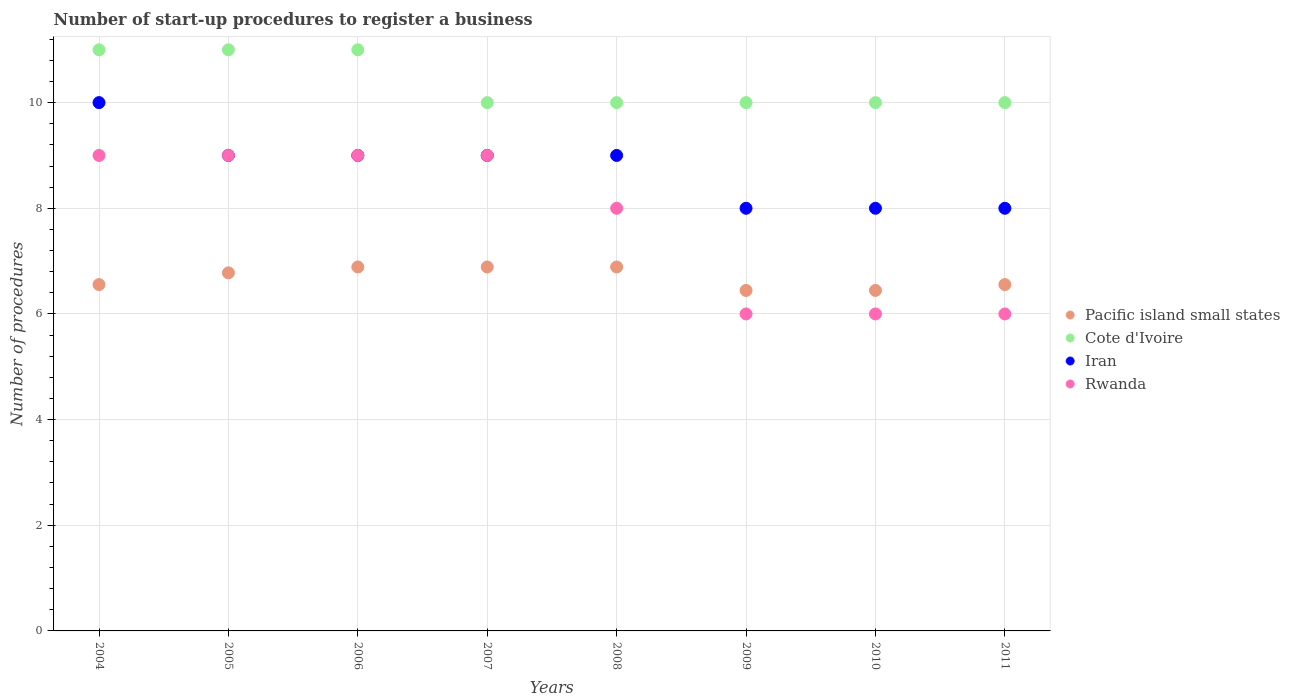How many different coloured dotlines are there?
Provide a short and direct response. 4. What is the number of procedures required to register a business in Iran in 2009?
Give a very brief answer. 8. Across all years, what is the maximum number of procedures required to register a business in Pacific island small states?
Offer a terse response. 6.89. Across all years, what is the minimum number of procedures required to register a business in Cote d'Ivoire?
Provide a short and direct response. 10. In which year was the number of procedures required to register a business in Rwanda maximum?
Your answer should be very brief. 2004. What is the total number of procedures required to register a business in Cote d'Ivoire in the graph?
Ensure brevity in your answer.  83. What is the difference between the number of procedures required to register a business in Cote d'Ivoire in 2009 and that in 2010?
Ensure brevity in your answer.  0. What is the difference between the number of procedures required to register a business in Rwanda in 2006 and the number of procedures required to register a business in Pacific island small states in 2004?
Your answer should be compact. 2.44. What is the average number of procedures required to register a business in Rwanda per year?
Provide a short and direct response. 7.75. In the year 2010, what is the difference between the number of procedures required to register a business in Pacific island small states and number of procedures required to register a business in Rwanda?
Your answer should be compact. 0.44. Is the difference between the number of procedures required to register a business in Pacific island small states in 2007 and 2009 greater than the difference between the number of procedures required to register a business in Rwanda in 2007 and 2009?
Offer a terse response. No. What is the difference between the highest and the lowest number of procedures required to register a business in Iran?
Offer a terse response. 2. In how many years, is the number of procedures required to register a business in Cote d'Ivoire greater than the average number of procedures required to register a business in Cote d'Ivoire taken over all years?
Provide a succinct answer. 3. Does the number of procedures required to register a business in Cote d'Ivoire monotonically increase over the years?
Give a very brief answer. No. Is the number of procedures required to register a business in Iran strictly greater than the number of procedures required to register a business in Rwanda over the years?
Your answer should be compact. No. Is the number of procedures required to register a business in Cote d'Ivoire strictly less than the number of procedures required to register a business in Rwanda over the years?
Offer a very short reply. No. How many dotlines are there?
Your response must be concise. 4. Does the graph contain any zero values?
Your answer should be very brief. No. Does the graph contain grids?
Your answer should be very brief. Yes. Where does the legend appear in the graph?
Provide a succinct answer. Center right. How are the legend labels stacked?
Your answer should be very brief. Vertical. What is the title of the graph?
Your answer should be compact. Number of start-up procedures to register a business. Does "Argentina" appear as one of the legend labels in the graph?
Keep it short and to the point. No. What is the label or title of the X-axis?
Your response must be concise. Years. What is the label or title of the Y-axis?
Make the answer very short. Number of procedures. What is the Number of procedures in Pacific island small states in 2004?
Keep it short and to the point. 6.56. What is the Number of procedures of Cote d'Ivoire in 2004?
Give a very brief answer. 11. What is the Number of procedures in Iran in 2004?
Your answer should be compact. 10. What is the Number of procedures of Pacific island small states in 2005?
Offer a terse response. 6.78. What is the Number of procedures in Cote d'Ivoire in 2005?
Keep it short and to the point. 11. What is the Number of procedures in Rwanda in 2005?
Your answer should be compact. 9. What is the Number of procedures of Pacific island small states in 2006?
Keep it short and to the point. 6.89. What is the Number of procedures in Rwanda in 2006?
Keep it short and to the point. 9. What is the Number of procedures of Pacific island small states in 2007?
Offer a very short reply. 6.89. What is the Number of procedures of Cote d'Ivoire in 2007?
Offer a very short reply. 10. What is the Number of procedures of Rwanda in 2007?
Give a very brief answer. 9. What is the Number of procedures of Pacific island small states in 2008?
Make the answer very short. 6.89. What is the Number of procedures of Cote d'Ivoire in 2008?
Offer a terse response. 10. What is the Number of procedures in Rwanda in 2008?
Your answer should be very brief. 8. What is the Number of procedures of Pacific island small states in 2009?
Ensure brevity in your answer.  6.44. What is the Number of procedures in Rwanda in 2009?
Ensure brevity in your answer.  6. What is the Number of procedures of Pacific island small states in 2010?
Your answer should be compact. 6.44. What is the Number of procedures in Rwanda in 2010?
Provide a succinct answer. 6. What is the Number of procedures of Pacific island small states in 2011?
Your response must be concise. 6.56. What is the Number of procedures of Rwanda in 2011?
Ensure brevity in your answer.  6. Across all years, what is the maximum Number of procedures in Pacific island small states?
Keep it short and to the point. 6.89. Across all years, what is the minimum Number of procedures in Pacific island small states?
Offer a very short reply. 6.44. Across all years, what is the minimum Number of procedures in Iran?
Give a very brief answer. 8. Across all years, what is the minimum Number of procedures in Rwanda?
Your answer should be very brief. 6. What is the total Number of procedures in Pacific island small states in the graph?
Ensure brevity in your answer.  53.44. What is the total Number of procedures in Cote d'Ivoire in the graph?
Provide a short and direct response. 83. What is the total Number of procedures of Iran in the graph?
Ensure brevity in your answer.  70. What is the difference between the Number of procedures in Pacific island small states in 2004 and that in 2005?
Make the answer very short. -0.22. What is the difference between the Number of procedures in Iran in 2004 and that in 2006?
Your answer should be very brief. 1. What is the difference between the Number of procedures in Rwanda in 2004 and that in 2006?
Ensure brevity in your answer.  0. What is the difference between the Number of procedures in Pacific island small states in 2004 and that in 2007?
Keep it short and to the point. -0.33. What is the difference between the Number of procedures in Cote d'Ivoire in 2004 and that in 2007?
Provide a short and direct response. 1. What is the difference between the Number of procedures of Iran in 2004 and that in 2007?
Offer a terse response. 1. What is the difference between the Number of procedures of Rwanda in 2004 and that in 2007?
Provide a succinct answer. 0. What is the difference between the Number of procedures of Pacific island small states in 2004 and that in 2008?
Keep it short and to the point. -0.33. What is the difference between the Number of procedures of Iran in 2004 and that in 2008?
Make the answer very short. 1. What is the difference between the Number of procedures in Rwanda in 2004 and that in 2008?
Ensure brevity in your answer.  1. What is the difference between the Number of procedures in Cote d'Ivoire in 2004 and that in 2009?
Ensure brevity in your answer.  1. What is the difference between the Number of procedures of Cote d'Ivoire in 2004 and that in 2010?
Your answer should be compact. 1. What is the difference between the Number of procedures of Rwanda in 2004 and that in 2010?
Make the answer very short. 3. What is the difference between the Number of procedures in Pacific island small states in 2004 and that in 2011?
Your answer should be compact. 0. What is the difference between the Number of procedures of Cote d'Ivoire in 2004 and that in 2011?
Your response must be concise. 1. What is the difference between the Number of procedures of Iran in 2004 and that in 2011?
Ensure brevity in your answer.  2. What is the difference between the Number of procedures in Pacific island small states in 2005 and that in 2006?
Ensure brevity in your answer.  -0.11. What is the difference between the Number of procedures of Rwanda in 2005 and that in 2006?
Your answer should be compact. 0. What is the difference between the Number of procedures in Pacific island small states in 2005 and that in 2007?
Provide a short and direct response. -0.11. What is the difference between the Number of procedures of Iran in 2005 and that in 2007?
Provide a succinct answer. 0. What is the difference between the Number of procedures of Rwanda in 2005 and that in 2007?
Provide a succinct answer. 0. What is the difference between the Number of procedures of Pacific island small states in 2005 and that in 2008?
Your answer should be very brief. -0.11. What is the difference between the Number of procedures of Iran in 2005 and that in 2008?
Offer a very short reply. 0. What is the difference between the Number of procedures of Pacific island small states in 2005 and that in 2009?
Ensure brevity in your answer.  0.33. What is the difference between the Number of procedures in Iran in 2005 and that in 2009?
Your response must be concise. 1. What is the difference between the Number of procedures of Pacific island small states in 2005 and that in 2010?
Your answer should be compact. 0.33. What is the difference between the Number of procedures in Rwanda in 2005 and that in 2010?
Provide a short and direct response. 3. What is the difference between the Number of procedures of Pacific island small states in 2005 and that in 2011?
Your answer should be very brief. 0.22. What is the difference between the Number of procedures of Cote d'Ivoire in 2005 and that in 2011?
Your answer should be very brief. 1. What is the difference between the Number of procedures of Iran in 2005 and that in 2011?
Your response must be concise. 1. What is the difference between the Number of procedures in Cote d'Ivoire in 2006 and that in 2007?
Your answer should be very brief. 1. What is the difference between the Number of procedures in Rwanda in 2006 and that in 2007?
Offer a very short reply. 0. What is the difference between the Number of procedures in Pacific island small states in 2006 and that in 2008?
Provide a succinct answer. 0. What is the difference between the Number of procedures in Rwanda in 2006 and that in 2008?
Offer a terse response. 1. What is the difference between the Number of procedures of Pacific island small states in 2006 and that in 2009?
Keep it short and to the point. 0.44. What is the difference between the Number of procedures of Cote d'Ivoire in 2006 and that in 2009?
Ensure brevity in your answer.  1. What is the difference between the Number of procedures in Iran in 2006 and that in 2009?
Keep it short and to the point. 1. What is the difference between the Number of procedures of Pacific island small states in 2006 and that in 2010?
Make the answer very short. 0.44. What is the difference between the Number of procedures of Cote d'Ivoire in 2006 and that in 2010?
Ensure brevity in your answer.  1. What is the difference between the Number of procedures in Rwanda in 2006 and that in 2010?
Your response must be concise. 3. What is the difference between the Number of procedures in Pacific island small states in 2006 and that in 2011?
Your response must be concise. 0.33. What is the difference between the Number of procedures of Cote d'Ivoire in 2006 and that in 2011?
Your answer should be compact. 1. What is the difference between the Number of procedures in Pacific island small states in 2007 and that in 2008?
Give a very brief answer. 0. What is the difference between the Number of procedures of Iran in 2007 and that in 2008?
Ensure brevity in your answer.  0. What is the difference between the Number of procedures in Rwanda in 2007 and that in 2008?
Offer a very short reply. 1. What is the difference between the Number of procedures of Pacific island small states in 2007 and that in 2009?
Ensure brevity in your answer.  0.44. What is the difference between the Number of procedures of Rwanda in 2007 and that in 2009?
Keep it short and to the point. 3. What is the difference between the Number of procedures of Pacific island small states in 2007 and that in 2010?
Keep it short and to the point. 0.44. What is the difference between the Number of procedures of Pacific island small states in 2007 and that in 2011?
Provide a succinct answer. 0.33. What is the difference between the Number of procedures of Iran in 2007 and that in 2011?
Make the answer very short. 1. What is the difference between the Number of procedures in Pacific island small states in 2008 and that in 2009?
Your answer should be very brief. 0.44. What is the difference between the Number of procedures in Pacific island small states in 2008 and that in 2010?
Ensure brevity in your answer.  0.44. What is the difference between the Number of procedures of Cote d'Ivoire in 2008 and that in 2010?
Offer a terse response. 0. What is the difference between the Number of procedures in Rwanda in 2008 and that in 2010?
Provide a short and direct response. 2. What is the difference between the Number of procedures in Pacific island small states in 2008 and that in 2011?
Make the answer very short. 0.33. What is the difference between the Number of procedures in Cote d'Ivoire in 2008 and that in 2011?
Keep it short and to the point. 0. What is the difference between the Number of procedures in Rwanda in 2008 and that in 2011?
Your answer should be very brief. 2. What is the difference between the Number of procedures in Iran in 2009 and that in 2010?
Provide a succinct answer. 0. What is the difference between the Number of procedures in Pacific island small states in 2009 and that in 2011?
Keep it short and to the point. -0.11. What is the difference between the Number of procedures of Cote d'Ivoire in 2009 and that in 2011?
Offer a very short reply. 0. What is the difference between the Number of procedures of Iran in 2009 and that in 2011?
Your answer should be compact. 0. What is the difference between the Number of procedures of Rwanda in 2009 and that in 2011?
Offer a very short reply. 0. What is the difference between the Number of procedures in Pacific island small states in 2010 and that in 2011?
Provide a short and direct response. -0.11. What is the difference between the Number of procedures of Rwanda in 2010 and that in 2011?
Your response must be concise. 0. What is the difference between the Number of procedures of Pacific island small states in 2004 and the Number of procedures of Cote d'Ivoire in 2005?
Provide a short and direct response. -4.44. What is the difference between the Number of procedures of Pacific island small states in 2004 and the Number of procedures of Iran in 2005?
Provide a short and direct response. -2.44. What is the difference between the Number of procedures of Pacific island small states in 2004 and the Number of procedures of Rwanda in 2005?
Ensure brevity in your answer.  -2.44. What is the difference between the Number of procedures in Cote d'Ivoire in 2004 and the Number of procedures in Iran in 2005?
Your answer should be compact. 2. What is the difference between the Number of procedures in Iran in 2004 and the Number of procedures in Rwanda in 2005?
Give a very brief answer. 1. What is the difference between the Number of procedures in Pacific island small states in 2004 and the Number of procedures in Cote d'Ivoire in 2006?
Offer a very short reply. -4.44. What is the difference between the Number of procedures of Pacific island small states in 2004 and the Number of procedures of Iran in 2006?
Your answer should be compact. -2.44. What is the difference between the Number of procedures in Pacific island small states in 2004 and the Number of procedures in Rwanda in 2006?
Keep it short and to the point. -2.44. What is the difference between the Number of procedures in Cote d'Ivoire in 2004 and the Number of procedures in Iran in 2006?
Keep it short and to the point. 2. What is the difference between the Number of procedures in Cote d'Ivoire in 2004 and the Number of procedures in Rwanda in 2006?
Give a very brief answer. 2. What is the difference between the Number of procedures of Pacific island small states in 2004 and the Number of procedures of Cote d'Ivoire in 2007?
Ensure brevity in your answer.  -3.44. What is the difference between the Number of procedures in Pacific island small states in 2004 and the Number of procedures in Iran in 2007?
Your response must be concise. -2.44. What is the difference between the Number of procedures of Pacific island small states in 2004 and the Number of procedures of Rwanda in 2007?
Your answer should be very brief. -2.44. What is the difference between the Number of procedures in Cote d'Ivoire in 2004 and the Number of procedures in Iran in 2007?
Provide a short and direct response. 2. What is the difference between the Number of procedures of Pacific island small states in 2004 and the Number of procedures of Cote d'Ivoire in 2008?
Give a very brief answer. -3.44. What is the difference between the Number of procedures in Pacific island small states in 2004 and the Number of procedures in Iran in 2008?
Offer a very short reply. -2.44. What is the difference between the Number of procedures in Pacific island small states in 2004 and the Number of procedures in Rwanda in 2008?
Offer a terse response. -1.44. What is the difference between the Number of procedures in Cote d'Ivoire in 2004 and the Number of procedures in Iran in 2008?
Offer a terse response. 2. What is the difference between the Number of procedures in Iran in 2004 and the Number of procedures in Rwanda in 2008?
Ensure brevity in your answer.  2. What is the difference between the Number of procedures of Pacific island small states in 2004 and the Number of procedures of Cote d'Ivoire in 2009?
Your answer should be compact. -3.44. What is the difference between the Number of procedures in Pacific island small states in 2004 and the Number of procedures in Iran in 2009?
Your answer should be compact. -1.44. What is the difference between the Number of procedures of Pacific island small states in 2004 and the Number of procedures of Rwanda in 2009?
Your response must be concise. 0.56. What is the difference between the Number of procedures of Cote d'Ivoire in 2004 and the Number of procedures of Iran in 2009?
Provide a short and direct response. 3. What is the difference between the Number of procedures of Cote d'Ivoire in 2004 and the Number of procedures of Rwanda in 2009?
Your answer should be compact. 5. What is the difference between the Number of procedures of Pacific island small states in 2004 and the Number of procedures of Cote d'Ivoire in 2010?
Offer a very short reply. -3.44. What is the difference between the Number of procedures of Pacific island small states in 2004 and the Number of procedures of Iran in 2010?
Offer a very short reply. -1.44. What is the difference between the Number of procedures of Pacific island small states in 2004 and the Number of procedures of Rwanda in 2010?
Provide a short and direct response. 0.56. What is the difference between the Number of procedures of Cote d'Ivoire in 2004 and the Number of procedures of Iran in 2010?
Ensure brevity in your answer.  3. What is the difference between the Number of procedures of Iran in 2004 and the Number of procedures of Rwanda in 2010?
Provide a short and direct response. 4. What is the difference between the Number of procedures in Pacific island small states in 2004 and the Number of procedures in Cote d'Ivoire in 2011?
Make the answer very short. -3.44. What is the difference between the Number of procedures of Pacific island small states in 2004 and the Number of procedures of Iran in 2011?
Your response must be concise. -1.44. What is the difference between the Number of procedures of Pacific island small states in 2004 and the Number of procedures of Rwanda in 2011?
Give a very brief answer. 0.56. What is the difference between the Number of procedures of Cote d'Ivoire in 2004 and the Number of procedures of Iran in 2011?
Make the answer very short. 3. What is the difference between the Number of procedures of Iran in 2004 and the Number of procedures of Rwanda in 2011?
Your response must be concise. 4. What is the difference between the Number of procedures of Pacific island small states in 2005 and the Number of procedures of Cote d'Ivoire in 2006?
Give a very brief answer. -4.22. What is the difference between the Number of procedures in Pacific island small states in 2005 and the Number of procedures in Iran in 2006?
Make the answer very short. -2.22. What is the difference between the Number of procedures of Pacific island small states in 2005 and the Number of procedures of Rwanda in 2006?
Make the answer very short. -2.22. What is the difference between the Number of procedures in Cote d'Ivoire in 2005 and the Number of procedures in Rwanda in 2006?
Keep it short and to the point. 2. What is the difference between the Number of procedures in Pacific island small states in 2005 and the Number of procedures in Cote d'Ivoire in 2007?
Make the answer very short. -3.22. What is the difference between the Number of procedures in Pacific island small states in 2005 and the Number of procedures in Iran in 2007?
Offer a terse response. -2.22. What is the difference between the Number of procedures of Pacific island small states in 2005 and the Number of procedures of Rwanda in 2007?
Make the answer very short. -2.22. What is the difference between the Number of procedures of Cote d'Ivoire in 2005 and the Number of procedures of Iran in 2007?
Offer a very short reply. 2. What is the difference between the Number of procedures in Cote d'Ivoire in 2005 and the Number of procedures in Rwanda in 2007?
Offer a terse response. 2. What is the difference between the Number of procedures in Pacific island small states in 2005 and the Number of procedures in Cote d'Ivoire in 2008?
Give a very brief answer. -3.22. What is the difference between the Number of procedures in Pacific island small states in 2005 and the Number of procedures in Iran in 2008?
Your answer should be very brief. -2.22. What is the difference between the Number of procedures of Pacific island small states in 2005 and the Number of procedures of Rwanda in 2008?
Your answer should be very brief. -1.22. What is the difference between the Number of procedures in Cote d'Ivoire in 2005 and the Number of procedures in Iran in 2008?
Give a very brief answer. 2. What is the difference between the Number of procedures in Pacific island small states in 2005 and the Number of procedures in Cote d'Ivoire in 2009?
Give a very brief answer. -3.22. What is the difference between the Number of procedures in Pacific island small states in 2005 and the Number of procedures in Iran in 2009?
Ensure brevity in your answer.  -1.22. What is the difference between the Number of procedures of Cote d'Ivoire in 2005 and the Number of procedures of Iran in 2009?
Offer a very short reply. 3. What is the difference between the Number of procedures in Cote d'Ivoire in 2005 and the Number of procedures in Rwanda in 2009?
Provide a short and direct response. 5. What is the difference between the Number of procedures in Pacific island small states in 2005 and the Number of procedures in Cote d'Ivoire in 2010?
Your answer should be very brief. -3.22. What is the difference between the Number of procedures of Pacific island small states in 2005 and the Number of procedures of Iran in 2010?
Offer a very short reply. -1.22. What is the difference between the Number of procedures of Pacific island small states in 2005 and the Number of procedures of Rwanda in 2010?
Offer a terse response. 0.78. What is the difference between the Number of procedures in Cote d'Ivoire in 2005 and the Number of procedures in Iran in 2010?
Offer a very short reply. 3. What is the difference between the Number of procedures of Pacific island small states in 2005 and the Number of procedures of Cote d'Ivoire in 2011?
Your response must be concise. -3.22. What is the difference between the Number of procedures of Pacific island small states in 2005 and the Number of procedures of Iran in 2011?
Provide a short and direct response. -1.22. What is the difference between the Number of procedures of Pacific island small states in 2006 and the Number of procedures of Cote d'Ivoire in 2007?
Your answer should be compact. -3.11. What is the difference between the Number of procedures of Pacific island small states in 2006 and the Number of procedures of Iran in 2007?
Make the answer very short. -2.11. What is the difference between the Number of procedures of Pacific island small states in 2006 and the Number of procedures of Rwanda in 2007?
Provide a succinct answer. -2.11. What is the difference between the Number of procedures in Cote d'Ivoire in 2006 and the Number of procedures in Rwanda in 2007?
Make the answer very short. 2. What is the difference between the Number of procedures of Pacific island small states in 2006 and the Number of procedures of Cote d'Ivoire in 2008?
Offer a very short reply. -3.11. What is the difference between the Number of procedures of Pacific island small states in 2006 and the Number of procedures of Iran in 2008?
Your answer should be very brief. -2.11. What is the difference between the Number of procedures in Pacific island small states in 2006 and the Number of procedures in Rwanda in 2008?
Your answer should be compact. -1.11. What is the difference between the Number of procedures of Cote d'Ivoire in 2006 and the Number of procedures of Iran in 2008?
Make the answer very short. 2. What is the difference between the Number of procedures of Iran in 2006 and the Number of procedures of Rwanda in 2008?
Give a very brief answer. 1. What is the difference between the Number of procedures in Pacific island small states in 2006 and the Number of procedures in Cote d'Ivoire in 2009?
Ensure brevity in your answer.  -3.11. What is the difference between the Number of procedures of Pacific island small states in 2006 and the Number of procedures of Iran in 2009?
Your answer should be very brief. -1.11. What is the difference between the Number of procedures in Cote d'Ivoire in 2006 and the Number of procedures in Iran in 2009?
Ensure brevity in your answer.  3. What is the difference between the Number of procedures in Cote d'Ivoire in 2006 and the Number of procedures in Rwanda in 2009?
Your answer should be compact. 5. What is the difference between the Number of procedures in Pacific island small states in 2006 and the Number of procedures in Cote d'Ivoire in 2010?
Give a very brief answer. -3.11. What is the difference between the Number of procedures in Pacific island small states in 2006 and the Number of procedures in Iran in 2010?
Your answer should be very brief. -1.11. What is the difference between the Number of procedures of Cote d'Ivoire in 2006 and the Number of procedures of Iran in 2010?
Provide a short and direct response. 3. What is the difference between the Number of procedures of Cote d'Ivoire in 2006 and the Number of procedures of Rwanda in 2010?
Offer a terse response. 5. What is the difference between the Number of procedures in Iran in 2006 and the Number of procedures in Rwanda in 2010?
Keep it short and to the point. 3. What is the difference between the Number of procedures in Pacific island small states in 2006 and the Number of procedures in Cote d'Ivoire in 2011?
Provide a succinct answer. -3.11. What is the difference between the Number of procedures of Pacific island small states in 2006 and the Number of procedures of Iran in 2011?
Your answer should be very brief. -1.11. What is the difference between the Number of procedures of Cote d'Ivoire in 2006 and the Number of procedures of Rwanda in 2011?
Provide a short and direct response. 5. What is the difference between the Number of procedures of Pacific island small states in 2007 and the Number of procedures of Cote d'Ivoire in 2008?
Offer a very short reply. -3.11. What is the difference between the Number of procedures of Pacific island small states in 2007 and the Number of procedures of Iran in 2008?
Make the answer very short. -2.11. What is the difference between the Number of procedures of Pacific island small states in 2007 and the Number of procedures of Rwanda in 2008?
Provide a succinct answer. -1.11. What is the difference between the Number of procedures in Pacific island small states in 2007 and the Number of procedures in Cote d'Ivoire in 2009?
Ensure brevity in your answer.  -3.11. What is the difference between the Number of procedures in Pacific island small states in 2007 and the Number of procedures in Iran in 2009?
Make the answer very short. -1.11. What is the difference between the Number of procedures of Pacific island small states in 2007 and the Number of procedures of Rwanda in 2009?
Make the answer very short. 0.89. What is the difference between the Number of procedures of Cote d'Ivoire in 2007 and the Number of procedures of Rwanda in 2009?
Provide a short and direct response. 4. What is the difference between the Number of procedures of Pacific island small states in 2007 and the Number of procedures of Cote d'Ivoire in 2010?
Make the answer very short. -3.11. What is the difference between the Number of procedures in Pacific island small states in 2007 and the Number of procedures in Iran in 2010?
Your answer should be compact. -1.11. What is the difference between the Number of procedures of Cote d'Ivoire in 2007 and the Number of procedures of Iran in 2010?
Provide a succinct answer. 2. What is the difference between the Number of procedures in Cote d'Ivoire in 2007 and the Number of procedures in Rwanda in 2010?
Offer a terse response. 4. What is the difference between the Number of procedures of Iran in 2007 and the Number of procedures of Rwanda in 2010?
Make the answer very short. 3. What is the difference between the Number of procedures of Pacific island small states in 2007 and the Number of procedures of Cote d'Ivoire in 2011?
Make the answer very short. -3.11. What is the difference between the Number of procedures of Pacific island small states in 2007 and the Number of procedures of Iran in 2011?
Make the answer very short. -1.11. What is the difference between the Number of procedures of Pacific island small states in 2007 and the Number of procedures of Rwanda in 2011?
Your answer should be very brief. 0.89. What is the difference between the Number of procedures in Cote d'Ivoire in 2007 and the Number of procedures in Rwanda in 2011?
Provide a short and direct response. 4. What is the difference between the Number of procedures in Pacific island small states in 2008 and the Number of procedures in Cote d'Ivoire in 2009?
Your answer should be very brief. -3.11. What is the difference between the Number of procedures in Pacific island small states in 2008 and the Number of procedures in Iran in 2009?
Your answer should be very brief. -1.11. What is the difference between the Number of procedures of Pacific island small states in 2008 and the Number of procedures of Rwanda in 2009?
Offer a terse response. 0.89. What is the difference between the Number of procedures of Iran in 2008 and the Number of procedures of Rwanda in 2009?
Offer a terse response. 3. What is the difference between the Number of procedures of Pacific island small states in 2008 and the Number of procedures of Cote d'Ivoire in 2010?
Your answer should be very brief. -3.11. What is the difference between the Number of procedures of Pacific island small states in 2008 and the Number of procedures of Iran in 2010?
Offer a terse response. -1.11. What is the difference between the Number of procedures in Pacific island small states in 2008 and the Number of procedures in Rwanda in 2010?
Your response must be concise. 0.89. What is the difference between the Number of procedures in Iran in 2008 and the Number of procedures in Rwanda in 2010?
Ensure brevity in your answer.  3. What is the difference between the Number of procedures in Pacific island small states in 2008 and the Number of procedures in Cote d'Ivoire in 2011?
Your response must be concise. -3.11. What is the difference between the Number of procedures in Pacific island small states in 2008 and the Number of procedures in Iran in 2011?
Your answer should be compact. -1.11. What is the difference between the Number of procedures of Pacific island small states in 2008 and the Number of procedures of Rwanda in 2011?
Your answer should be very brief. 0.89. What is the difference between the Number of procedures in Cote d'Ivoire in 2008 and the Number of procedures in Rwanda in 2011?
Offer a terse response. 4. What is the difference between the Number of procedures of Pacific island small states in 2009 and the Number of procedures of Cote d'Ivoire in 2010?
Keep it short and to the point. -3.56. What is the difference between the Number of procedures of Pacific island small states in 2009 and the Number of procedures of Iran in 2010?
Offer a terse response. -1.56. What is the difference between the Number of procedures of Pacific island small states in 2009 and the Number of procedures of Rwanda in 2010?
Your response must be concise. 0.44. What is the difference between the Number of procedures of Cote d'Ivoire in 2009 and the Number of procedures of Iran in 2010?
Offer a terse response. 2. What is the difference between the Number of procedures of Cote d'Ivoire in 2009 and the Number of procedures of Rwanda in 2010?
Make the answer very short. 4. What is the difference between the Number of procedures of Pacific island small states in 2009 and the Number of procedures of Cote d'Ivoire in 2011?
Provide a succinct answer. -3.56. What is the difference between the Number of procedures of Pacific island small states in 2009 and the Number of procedures of Iran in 2011?
Keep it short and to the point. -1.56. What is the difference between the Number of procedures of Pacific island small states in 2009 and the Number of procedures of Rwanda in 2011?
Offer a very short reply. 0.44. What is the difference between the Number of procedures in Cote d'Ivoire in 2009 and the Number of procedures in Rwanda in 2011?
Your answer should be very brief. 4. What is the difference between the Number of procedures of Pacific island small states in 2010 and the Number of procedures of Cote d'Ivoire in 2011?
Make the answer very short. -3.56. What is the difference between the Number of procedures in Pacific island small states in 2010 and the Number of procedures in Iran in 2011?
Provide a succinct answer. -1.56. What is the difference between the Number of procedures in Pacific island small states in 2010 and the Number of procedures in Rwanda in 2011?
Offer a terse response. 0.44. What is the difference between the Number of procedures in Cote d'Ivoire in 2010 and the Number of procedures in Rwanda in 2011?
Your answer should be very brief. 4. What is the average Number of procedures of Pacific island small states per year?
Make the answer very short. 6.68. What is the average Number of procedures in Cote d'Ivoire per year?
Your answer should be very brief. 10.38. What is the average Number of procedures of Iran per year?
Ensure brevity in your answer.  8.75. What is the average Number of procedures of Rwanda per year?
Ensure brevity in your answer.  7.75. In the year 2004, what is the difference between the Number of procedures of Pacific island small states and Number of procedures of Cote d'Ivoire?
Offer a very short reply. -4.44. In the year 2004, what is the difference between the Number of procedures in Pacific island small states and Number of procedures in Iran?
Offer a terse response. -3.44. In the year 2004, what is the difference between the Number of procedures in Pacific island small states and Number of procedures in Rwanda?
Your response must be concise. -2.44. In the year 2004, what is the difference between the Number of procedures of Cote d'Ivoire and Number of procedures of Iran?
Offer a terse response. 1. In the year 2005, what is the difference between the Number of procedures of Pacific island small states and Number of procedures of Cote d'Ivoire?
Make the answer very short. -4.22. In the year 2005, what is the difference between the Number of procedures in Pacific island small states and Number of procedures in Iran?
Offer a terse response. -2.22. In the year 2005, what is the difference between the Number of procedures in Pacific island small states and Number of procedures in Rwanda?
Offer a terse response. -2.22. In the year 2006, what is the difference between the Number of procedures in Pacific island small states and Number of procedures in Cote d'Ivoire?
Offer a terse response. -4.11. In the year 2006, what is the difference between the Number of procedures in Pacific island small states and Number of procedures in Iran?
Offer a very short reply. -2.11. In the year 2006, what is the difference between the Number of procedures in Pacific island small states and Number of procedures in Rwanda?
Offer a terse response. -2.11. In the year 2006, what is the difference between the Number of procedures of Iran and Number of procedures of Rwanda?
Provide a short and direct response. 0. In the year 2007, what is the difference between the Number of procedures in Pacific island small states and Number of procedures in Cote d'Ivoire?
Keep it short and to the point. -3.11. In the year 2007, what is the difference between the Number of procedures of Pacific island small states and Number of procedures of Iran?
Offer a terse response. -2.11. In the year 2007, what is the difference between the Number of procedures of Pacific island small states and Number of procedures of Rwanda?
Your response must be concise. -2.11. In the year 2007, what is the difference between the Number of procedures in Iran and Number of procedures in Rwanda?
Offer a very short reply. 0. In the year 2008, what is the difference between the Number of procedures in Pacific island small states and Number of procedures in Cote d'Ivoire?
Your response must be concise. -3.11. In the year 2008, what is the difference between the Number of procedures in Pacific island small states and Number of procedures in Iran?
Give a very brief answer. -2.11. In the year 2008, what is the difference between the Number of procedures of Pacific island small states and Number of procedures of Rwanda?
Offer a terse response. -1.11. In the year 2008, what is the difference between the Number of procedures in Cote d'Ivoire and Number of procedures in Iran?
Your answer should be very brief. 1. In the year 2008, what is the difference between the Number of procedures of Cote d'Ivoire and Number of procedures of Rwanda?
Provide a succinct answer. 2. In the year 2009, what is the difference between the Number of procedures of Pacific island small states and Number of procedures of Cote d'Ivoire?
Make the answer very short. -3.56. In the year 2009, what is the difference between the Number of procedures in Pacific island small states and Number of procedures in Iran?
Give a very brief answer. -1.56. In the year 2009, what is the difference between the Number of procedures of Pacific island small states and Number of procedures of Rwanda?
Make the answer very short. 0.44. In the year 2009, what is the difference between the Number of procedures in Iran and Number of procedures in Rwanda?
Ensure brevity in your answer.  2. In the year 2010, what is the difference between the Number of procedures in Pacific island small states and Number of procedures in Cote d'Ivoire?
Offer a very short reply. -3.56. In the year 2010, what is the difference between the Number of procedures of Pacific island small states and Number of procedures of Iran?
Ensure brevity in your answer.  -1.56. In the year 2010, what is the difference between the Number of procedures in Pacific island small states and Number of procedures in Rwanda?
Provide a succinct answer. 0.44. In the year 2010, what is the difference between the Number of procedures in Cote d'Ivoire and Number of procedures in Rwanda?
Provide a short and direct response. 4. In the year 2010, what is the difference between the Number of procedures in Iran and Number of procedures in Rwanda?
Make the answer very short. 2. In the year 2011, what is the difference between the Number of procedures in Pacific island small states and Number of procedures in Cote d'Ivoire?
Make the answer very short. -3.44. In the year 2011, what is the difference between the Number of procedures of Pacific island small states and Number of procedures of Iran?
Ensure brevity in your answer.  -1.44. In the year 2011, what is the difference between the Number of procedures in Pacific island small states and Number of procedures in Rwanda?
Offer a terse response. 0.56. In the year 2011, what is the difference between the Number of procedures of Cote d'Ivoire and Number of procedures of Iran?
Keep it short and to the point. 2. In the year 2011, what is the difference between the Number of procedures in Iran and Number of procedures in Rwanda?
Ensure brevity in your answer.  2. What is the ratio of the Number of procedures of Pacific island small states in 2004 to that in 2005?
Your answer should be very brief. 0.97. What is the ratio of the Number of procedures of Cote d'Ivoire in 2004 to that in 2005?
Keep it short and to the point. 1. What is the ratio of the Number of procedures of Pacific island small states in 2004 to that in 2006?
Your answer should be compact. 0.95. What is the ratio of the Number of procedures in Cote d'Ivoire in 2004 to that in 2006?
Your answer should be very brief. 1. What is the ratio of the Number of procedures in Rwanda in 2004 to that in 2006?
Your answer should be compact. 1. What is the ratio of the Number of procedures of Pacific island small states in 2004 to that in 2007?
Keep it short and to the point. 0.95. What is the ratio of the Number of procedures of Pacific island small states in 2004 to that in 2008?
Give a very brief answer. 0.95. What is the ratio of the Number of procedures in Cote d'Ivoire in 2004 to that in 2008?
Provide a short and direct response. 1.1. What is the ratio of the Number of procedures of Iran in 2004 to that in 2008?
Provide a succinct answer. 1.11. What is the ratio of the Number of procedures of Pacific island small states in 2004 to that in 2009?
Ensure brevity in your answer.  1.02. What is the ratio of the Number of procedures of Pacific island small states in 2004 to that in 2010?
Your response must be concise. 1.02. What is the ratio of the Number of procedures of Cote d'Ivoire in 2004 to that in 2011?
Keep it short and to the point. 1.1. What is the ratio of the Number of procedures in Iran in 2004 to that in 2011?
Keep it short and to the point. 1.25. What is the ratio of the Number of procedures in Rwanda in 2004 to that in 2011?
Offer a terse response. 1.5. What is the ratio of the Number of procedures of Pacific island small states in 2005 to that in 2006?
Provide a succinct answer. 0.98. What is the ratio of the Number of procedures in Iran in 2005 to that in 2006?
Give a very brief answer. 1. What is the ratio of the Number of procedures of Pacific island small states in 2005 to that in 2007?
Offer a terse response. 0.98. What is the ratio of the Number of procedures of Iran in 2005 to that in 2007?
Your answer should be compact. 1. What is the ratio of the Number of procedures in Pacific island small states in 2005 to that in 2008?
Make the answer very short. 0.98. What is the ratio of the Number of procedures in Rwanda in 2005 to that in 2008?
Ensure brevity in your answer.  1.12. What is the ratio of the Number of procedures of Pacific island small states in 2005 to that in 2009?
Provide a succinct answer. 1.05. What is the ratio of the Number of procedures of Cote d'Ivoire in 2005 to that in 2009?
Ensure brevity in your answer.  1.1. What is the ratio of the Number of procedures in Iran in 2005 to that in 2009?
Keep it short and to the point. 1.12. What is the ratio of the Number of procedures in Rwanda in 2005 to that in 2009?
Your answer should be compact. 1.5. What is the ratio of the Number of procedures in Pacific island small states in 2005 to that in 2010?
Offer a terse response. 1.05. What is the ratio of the Number of procedures in Cote d'Ivoire in 2005 to that in 2010?
Make the answer very short. 1.1. What is the ratio of the Number of procedures in Iran in 2005 to that in 2010?
Provide a short and direct response. 1.12. What is the ratio of the Number of procedures of Rwanda in 2005 to that in 2010?
Your answer should be compact. 1.5. What is the ratio of the Number of procedures of Pacific island small states in 2005 to that in 2011?
Offer a terse response. 1.03. What is the ratio of the Number of procedures in Cote d'Ivoire in 2005 to that in 2011?
Keep it short and to the point. 1.1. What is the ratio of the Number of procedures of Iran in 2005 to that in 2011?
Provide a short and direct response. 1.12. What is the ratio of the Number of procedures of Cote d'Ivoire in 2006 to that in 2007?
Give a very brief answer. 1.1. What is the ratio of the Number of procedures of Pacific island small states in 2006 to that in 2008?
Give a very brief answer. 1. What is the ratio of the Number of procedures of Iran in 2006 to that in 2008?
Your answer should be compact. 1. What is the ratio of the Number of procedures in Pacific island small states in 2006 to that in 2009?
Your answer should be compact. 1.07. What is the ratio of the Number of procedures of Pacific island small states in 2006 to that in 2010?
Offer a very short reply. 1.07. What is the ratio of the Number of procedures of Cote d'Ivoire in 2006 to that in 2010?
Provide a succinct answer. 1.1. What is the ratio of the Number of procedures in Iran in 2006 to that in 2010?
Offer a terse response. 1.12. What is the ratio of the Number of procedures of Rwanda in 2006 to that in 2010?
Provide a short and direct response. 1.5. What is the ratio of the Number of procedures of Pacific island small states in 2006 to that in 2011?
Provide a short and direct response. 1.05. What is the ratio of the Number of procedures in Cote d'Ivoire in 2006 to that in 2011?
Make the answer very short. 1.1. What is the ratio of the Number of procedures of Iran in 2006 to that in 2011?
Ensure brevity in your answer.  1.12. What is the ratio of the Number of procedures of Pacific island small states in 2007 to that in 2008?
Offer a very short reply. 1. What is the ratio of the Number of procedures of Iran in 2007 to that in 2008?
Your answer should be compact. 1. What is the ratio of the Number of procedures in Pacific island small states in 2007 to that in 2009?
Offer a very short reply. 1.07. What is the ratio of the Number of procedures in Rwanda in 2007 to that in 2009?
Your answer should be very brief. 1.5. What is the ratio of the Number of procedures in Pacific island small states in 2007 to that in 2010?
Provide a succinct answer. 1.07. What is the ratio of the Number of procedures of Cote d'Ivoire in 2007 to that in 2010?
Make the answer very short. 1. What is the ratio of the Number of procedures in Iran in 2007 to that in 2010?
Offer a very short reply. 1.12. What is the ratio of the Number of procedures in Rwanda in 2007 to that in 2010?
Make the answer very short. 1.5. What is the ratio of the Number of procedures in Pacific island small states in 2007 to that in 2011?
Provide a succinct answer. 1.05. What is the ratio of the Number of procedures in Cote d'Ivoire in 2007 to that in 2011?
Keep it short and to the point. 1. What is the ratio of the Number of procedures of Rwanda in 2007 to that in 2011?
Your answer should be compact. 1.5. What is the ratio of the Number of procedures of Pacific island small states in 2008 to that in 2009?
Offer a very short reply. 1.07. What is the ratio of the Number of procedures of Cote d'Ivoire in 2008 to that in 2009?
Ensure brevity in your answer.  1. What is the ratio of the Number of procedures in Iran in 2008 to that in 2009?
Your answer should be very brief. 1.12. What is the ratio of the Number of procedures in Rwanda in 2008 to that in 2009?
Your answer should be compact. 1.33. What is the ratio of the Number of procedures in Pacific island small states in 2008 to that in 2010?
Give a very brief answer. 1.07. What is the ratio of the Number of procedures in Iran in 2008 to that in 2010?
Ensure brevity in your answer.  1.12. What is the ratio of the Number of procedures of Rwanda in 2008 to that in 2010?
Your answer should be compact. 1.33. What is the ratio of the Number of procedures of Pacific island small states in 2008 to that in 2011?
Give a very brief answer. 1.05. What is the ratio of the Number of procedures in Rwanda in 2008 to that in 2011?
Give a very brief answer. 1.33. What is the ratio of the Number of procedures in Cote d'Ivoire in 2009 to that in 2010?
Offer a terse response. 1. What is the ratio of the Number of procedures in Iran in 2009 to that in 2010?
Offer a terse response. 1. What is the ratio of the Number of procedures of Pacific island small states in 2009 to that in 2011?
Ensure brevity in your answer.  0.98. What is the ratio of the Number of procedures of Cote d'Ivoire in 2009 to that in 2011?
Provide a succinct answer. 1. What is the ratio of the Number of procedures in Rwanda in 2009 to that in 2011?
Your answer should be very brief. 1. What is the ratio of the Number of procedures of Pacific island small states in 2010 to that in 2011?
Offer a terse response. 0.98. What is the ratio of the Number of procedures of Cote d'Ivoire in 2010 to that in 2011?
Offer a very short reply. 1. What is the ratio of the Number of procedures of Iran in 2010 to that in 2011?
Ensure brevity in your answer.  1. What is the ratio of the Number of procedures in Rwanda in 2010 to that in 2011?
Provide a short and direct response. 1. What is the difference between the highest and the second highest Number of procedures in Iran?
Offer a very short reply. 1. What is the difference between the highest and the lowest Number of procedures of Pacific island small states?
Your answer should be compact. 0.44. What is the difference between the highest and the lowest Number of procedures in Cote d'Ivoire?
Keep it short and to the point. 1. What is the difference between the highest and the lowest Number of procedures of Iran?
Offer a terse response. 2. 